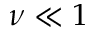Convert formula to latex. <formula><loc_0><loc_0><loc_500><loc_500>\nu \ll 1</formula> 